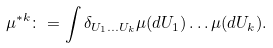Convert formula to latex. <formula><loc_0><loc_0><loc_500><loc_500>\mu ^ { * k } \colon = \int \delta _ { U _ { 1 } \dots U _ { k } } \mu ( d U _ { 1 } ) \dots \mu ( d U _ { k } ) .</formula> 